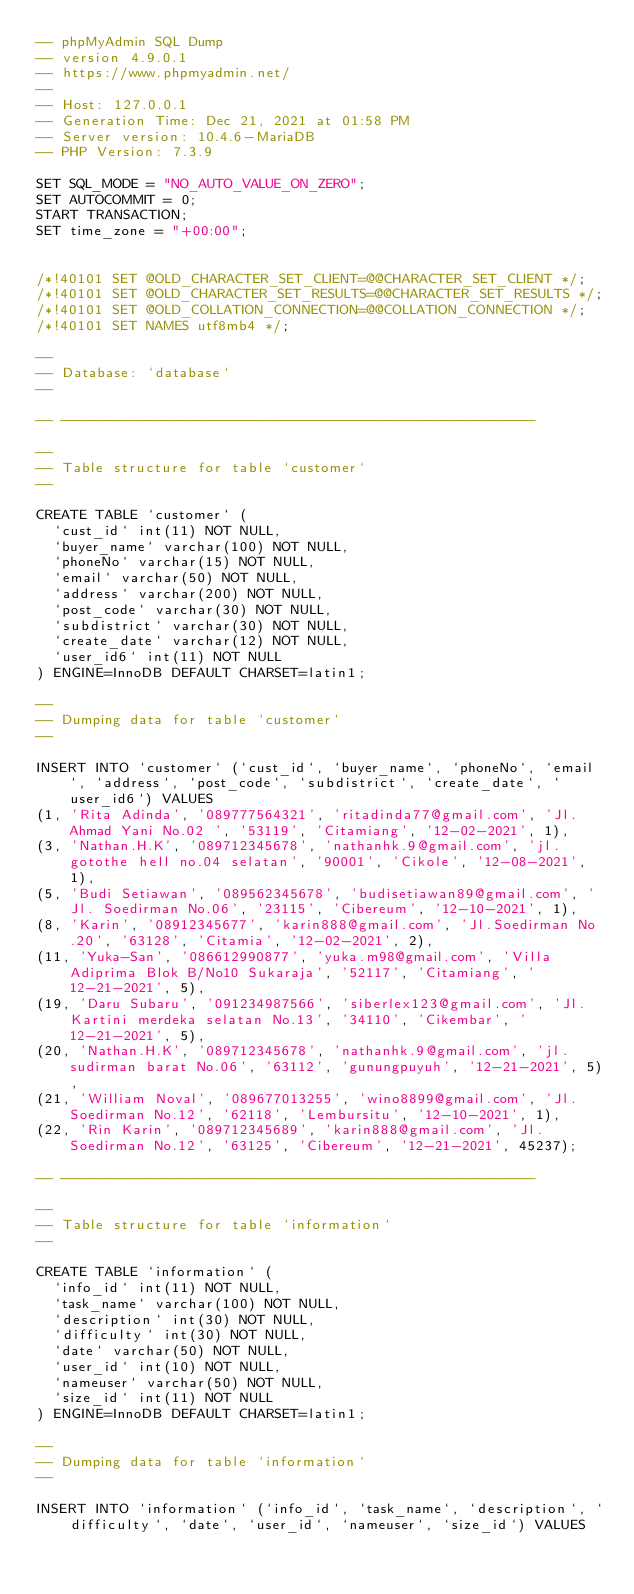Convert code to text. <code><loc_0><loc_0><loc_500><loc_500><_SQL_>-- phpMyAdmin SQL Dump
-- version 4.9.0.1
-- https://www.phpmyadmin.net/
--
-- Host: 127.0.0.1
-- Generation Time: Dec 21, 2021 at 01:58 PM
-- Server version: 10.4.6-MariaDB
-- PHP Version: 7.3.9

SET SQL_MODE = "NO_AUTO_VALUE_ON_ZERO";
SET AUTOCOMMIT = 0;
START TRANSACTION;
SET time_zone = "+00:00";


/*!40101 SET @OLD_CHARACTER_SET_CLIENT=@@CHARACTER_SET_CLIENT */;
/*!40101 SET @OLD_CHARACTER_SET_RESULTS=@@CHARACTER_SET_RESULTS */;
/*!40101 SET @OLD_COLLATION_CONNECTION=@@COLLATION_CONNECTION */;
/*!40101 SET NAMES utf8mb4 */;

--
-- Database: `database`
--

-- --------------------------------------------------------

--
-- Table structure for table `customer`
--

CREATE TABLE `customer` (
  `cust_id` int(11) NOT NULL,
  `buyer_name` varchar(100) NOT NULL,
  `phoneNo` varchar(15) NOT NULL,
  `email` varchar(50) NOT NULL,
  `address` varchar(200) NOT NULL,
  `post_code` varchar(30) NOT NULL,
  `subdistrict` varchar(30) NOT NULL,
  `create_date` varchar(12) NOT NULL,
  `user_id6` int(11) NOT NULL
) ENGINE=InnoDB DEFAULT CHARSET=latin1;

--
-- Dumping data for table `customer`
--

INSERT INTO `customer` (`cust_id`, `buyer_name`, `phoneNo`, `email`, `address`, `post_code`, `subdistrict`, `create_date`, `user_id6`) VALUES
(1, 'Rita Adinda', '089777564321', 'ritadinda77@gmail.com', 'Jl. Ahmad Yani No.02 ', '53119', 'Citamiang', '12-02-2021', 1),
(3, 'Nathan.H.K', '089712345678', 'nathanhk.9@gmail.com', 'jl. gotothe hell no.04 selatan', '90001', 'Cikole', '12-08-2021', 1),
(5, 'Budi Setiawan', '089562345678', 'budisetiawan89@gmail.com', 'Jl. Soedirman No.06', '23115', 'Cibereum', '12-10-2021', 1),
(8, 'Karin', '08912345677', 'karin888@gmail.com', 'Jl.Soedirman No.20', '63128', 'Citamia', '12-02-2021', 2),
(11, 'Yuka-San', '086612990877', 'yuka.m98@gmail.com', 'Villa Adiprima Blok B/No10 Sukaraja', '52117', 'Citamiang', '12-21-2021', 5),
(19, 'Daru Subaru', '091234987566', 'siberlex123@gmail.com', 'Jl. Kartini merdeka selatan No.13', '34110', 'Cikembar', '12-21-2021', 5),
(20, 'Nathan.H.K', '089712345678', 'nathanhk.9@gmail.com', 'jl.sudirman barat No.06', '63112', 'gunungpuyuh', '12-21-2021', 5),
(21, 'William Noval', '089677013255', 'wino8899@gmail.com', 'Jl.Soedirman No.12', '62118', 'Lembursitu', '12-10-2021', 1),
(22, 'Rin Karin', '089712345689', 'karin888@gmail.com', 'Jl.Soedirman No.12', '63125', 'Cibereum', '12-21-2021', 45237);

-- --------------------------------------------------------

--
-- Table structure for table `information`
--

CREATE TABLE `information` (
  `info_id` int(11) NOT NULL,
  `task_name` varchar(100) NOT NULL,
  `description` int(30) NOT NULL,
  `difficulty` int(30) NOT NULL,
  `date` varchar(50) NOT NULL,
  `user_id` int(10) NOT NULL,
  `nameuser` varchar(50) NOT NULL,
  `size_id` int(11) NOT NULL
) ENGINE=InnoDB DEFAULT CHARSET=latin1;

--
-- Dumping data for table `information`
--

INSERT INTO `information` (`info_id`, `task_name`, `description`, `difficulty`, `date`, `user_id`, `nameuser`, `size_id`) VALUES</code> 